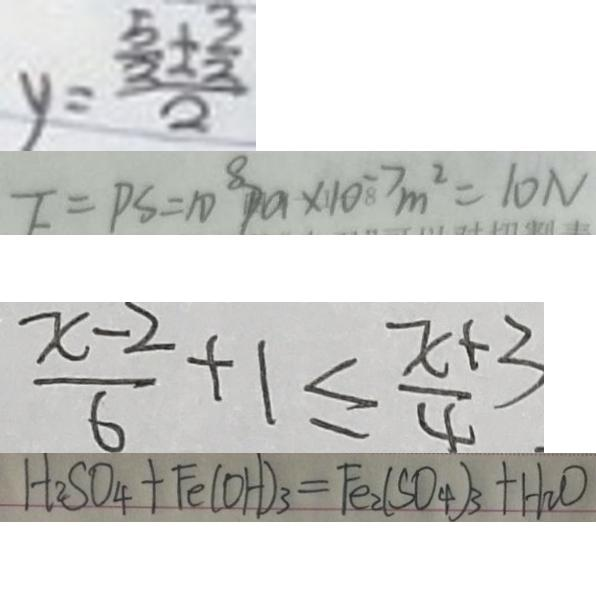Convert formula to latex. <formula><loc_0><loc_0><loc_500><loc_500>y = \frac { \frac { 5 } { 3 } \pm \frac { 3 } { 2 } } { 2 } 
 F = P S = 1 0 ^ { 8 } P a \times 1 0 ^ { - 7 } m ^ { 2 } = 1 0 N 
 \frac { x - 2 } { 6 } + 1 \leq \frac { x + 3 } { 4 } 
 H _ { 2 } S O _ { 4 } + F e ( O H ) _ { 3 } = F e _ { 2 } ( S O _ { 4 } ) _ { 3 } + H _ { 2 } O</formula> 